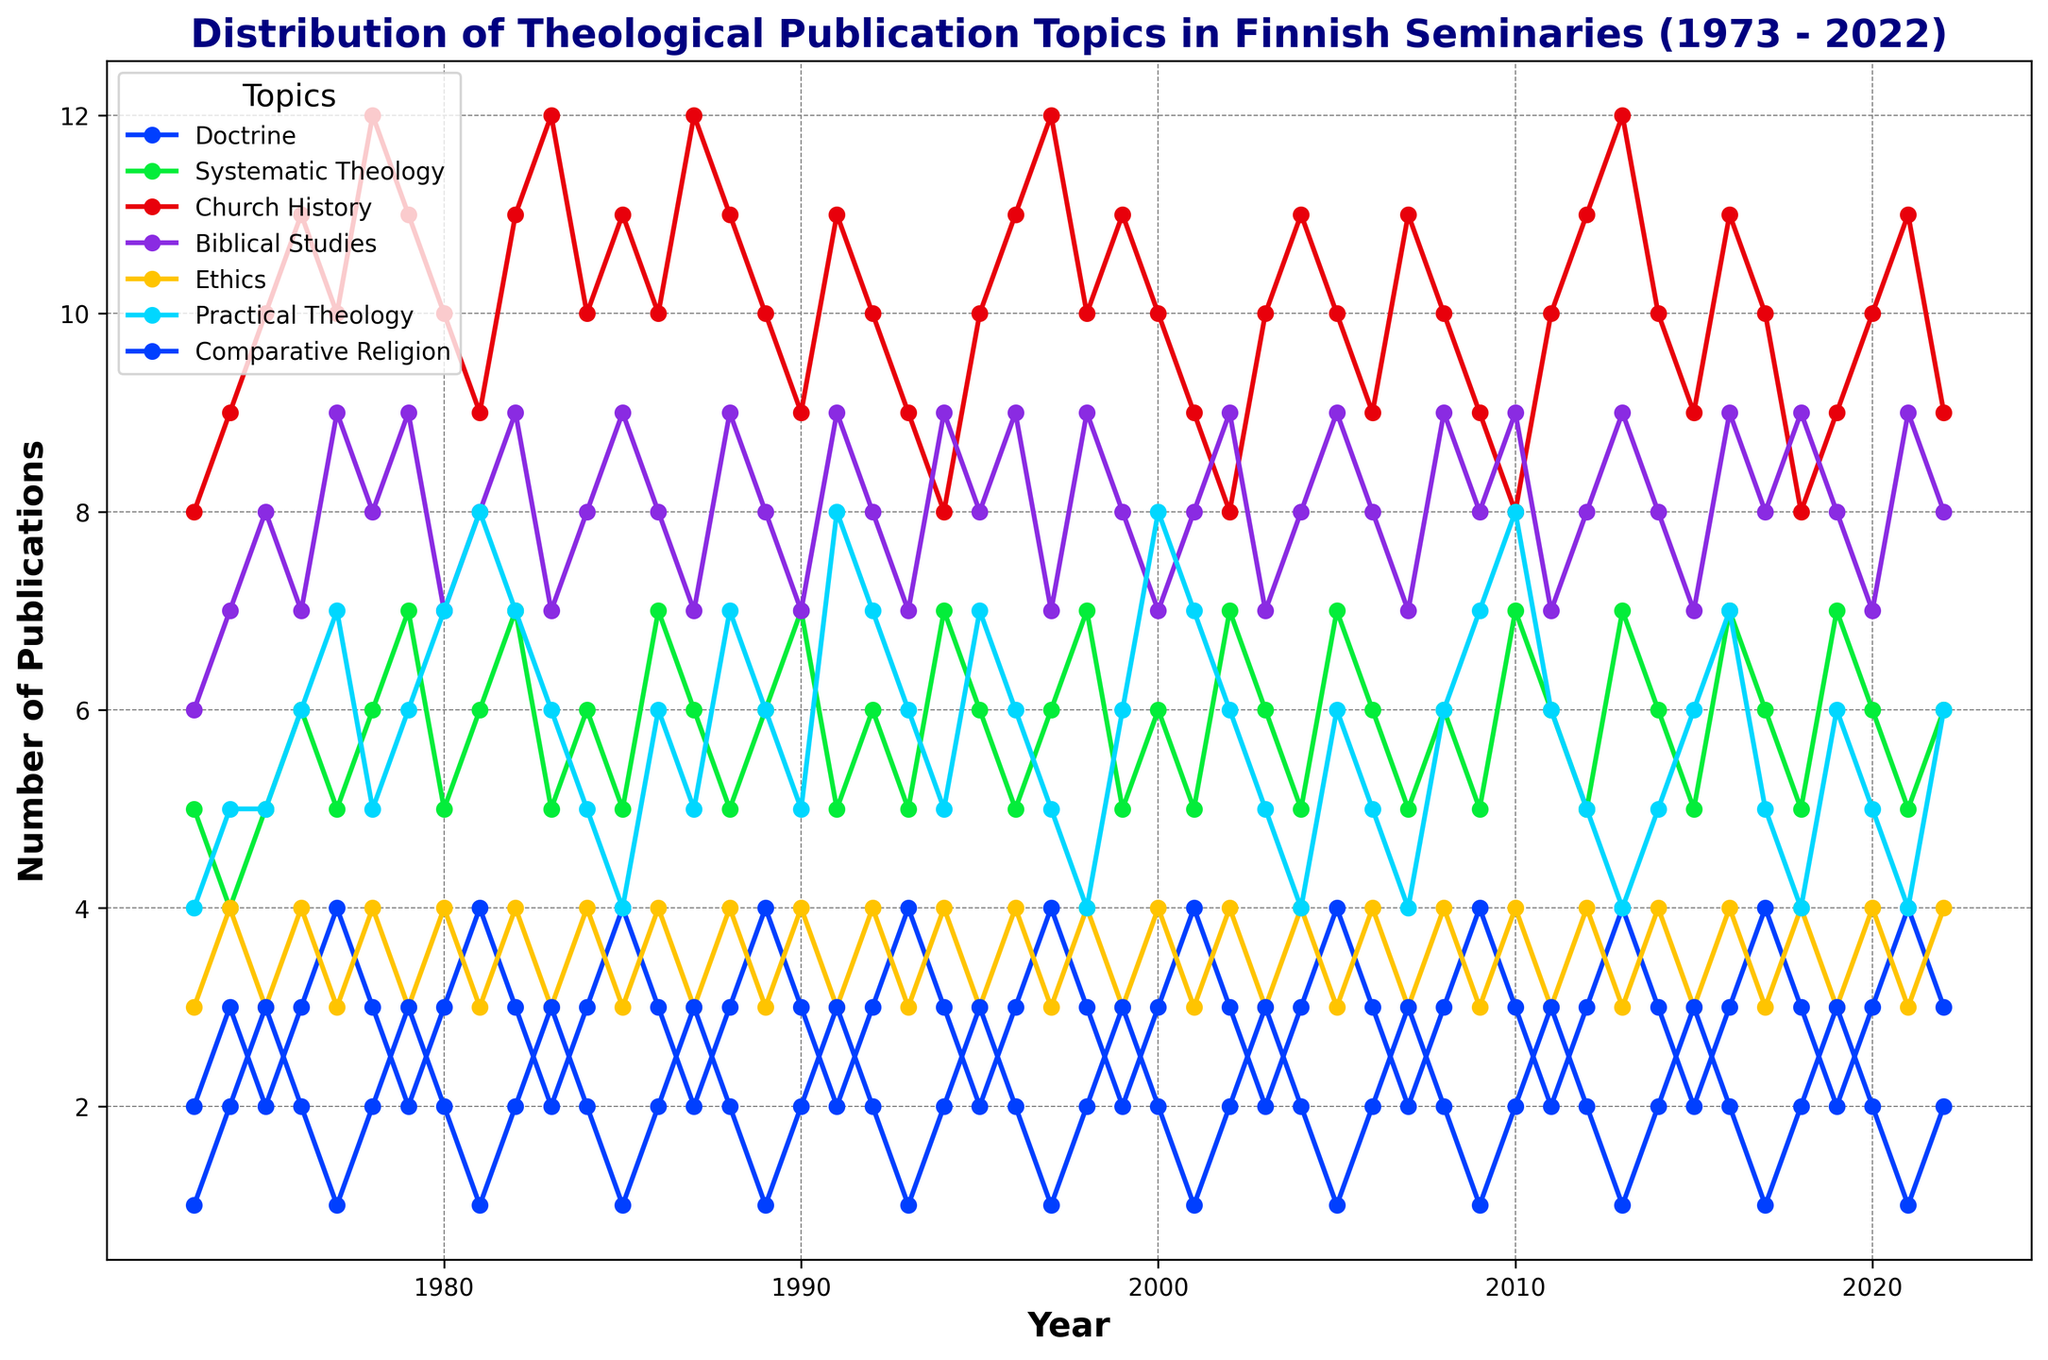What is the general trend for publications on Church History over the last 50 years? By observing the graph, we can see that the number of publications on Church History has had some fluctuations but generally remained high (around 9 to 12 publications per year).
Answer: High and steady In which year was the number of publications for Biblical Studies higher than for Systematic Theology? By comparing the values on the y-axis for each topic, it appears that in 1977, the number of publications on Biblical Studies was 9, which was higher than the 5 publications for Systematic Theology.
Answer: 1977 Which topic had the highest number of publications in a single year and what was that number? By looking at the peaks of each line graph, we find that Church History had the highest number in a single year, with 12 publications in several years (1978, 1983, 1987, 1997, and others).
Answer: Church History, 12 How does the number of publications on Comparative Religion in 1981 compare to that in 2001? In 1981, the number of Comparative Religion publications was 1, while in 2001 it was also 1. Both years have the same value.
Answer: Equal, 1 What is the average number of publications per year for Practical Theology over the entire period? Sum all the yearly publications for Practical Theology and then divide by the number of years (50). (4 + 5 + 5 + 6 + ... + 4) / 50 = 5.32
Answer: 5.32 On average, did Ethics have more publications than Doctrine? Sum all yearly publications for Ethics and Doctrine, then divide by the number of years for each. Ethics: (3 + 4 + 3 + ... + 4) / 50 = 3.52; Doctrine: (2 + 3 + 2 + ... + 3) / 50 = 3.06. Ethics had slightly more publications.
Answer: Yes In what year did Practical Theology have the strongest increase in its number of publications compared with the previous year? By checking the differences between consecutive years, from 1980 to 1981, the publication count jumped from 7 to 8, and from 1990 to 1991, it increased from 5 to 8. A 3-publication increase in 1991 is the highest.
Answer: 1991 Which topic had the most noticeable decline in publications after its peak year? By locating each peak and subsequent declines, Systematic Theology peaked at 12 in 1983 and saw a decrease in the next few years.
Answer: Systematic Theology Between 1980 and 1990, which topic had the most consistent number of publications? By examining the lines between 1980 and 1990, Biblical Studies seemed to have the most stable publications, ranging mildly around 7-9.
Answer: Biblical Studies Comparing 1973 and 2022, which topic saw the most significant increase in its number of publications? Calculate the differences: Church History increased from 8 to 9, Systematic Theology from 5 to 6, Practical Theology from 4 to 6. Practical Theology had the most noticeable gain.
Answer: Practical Theology 